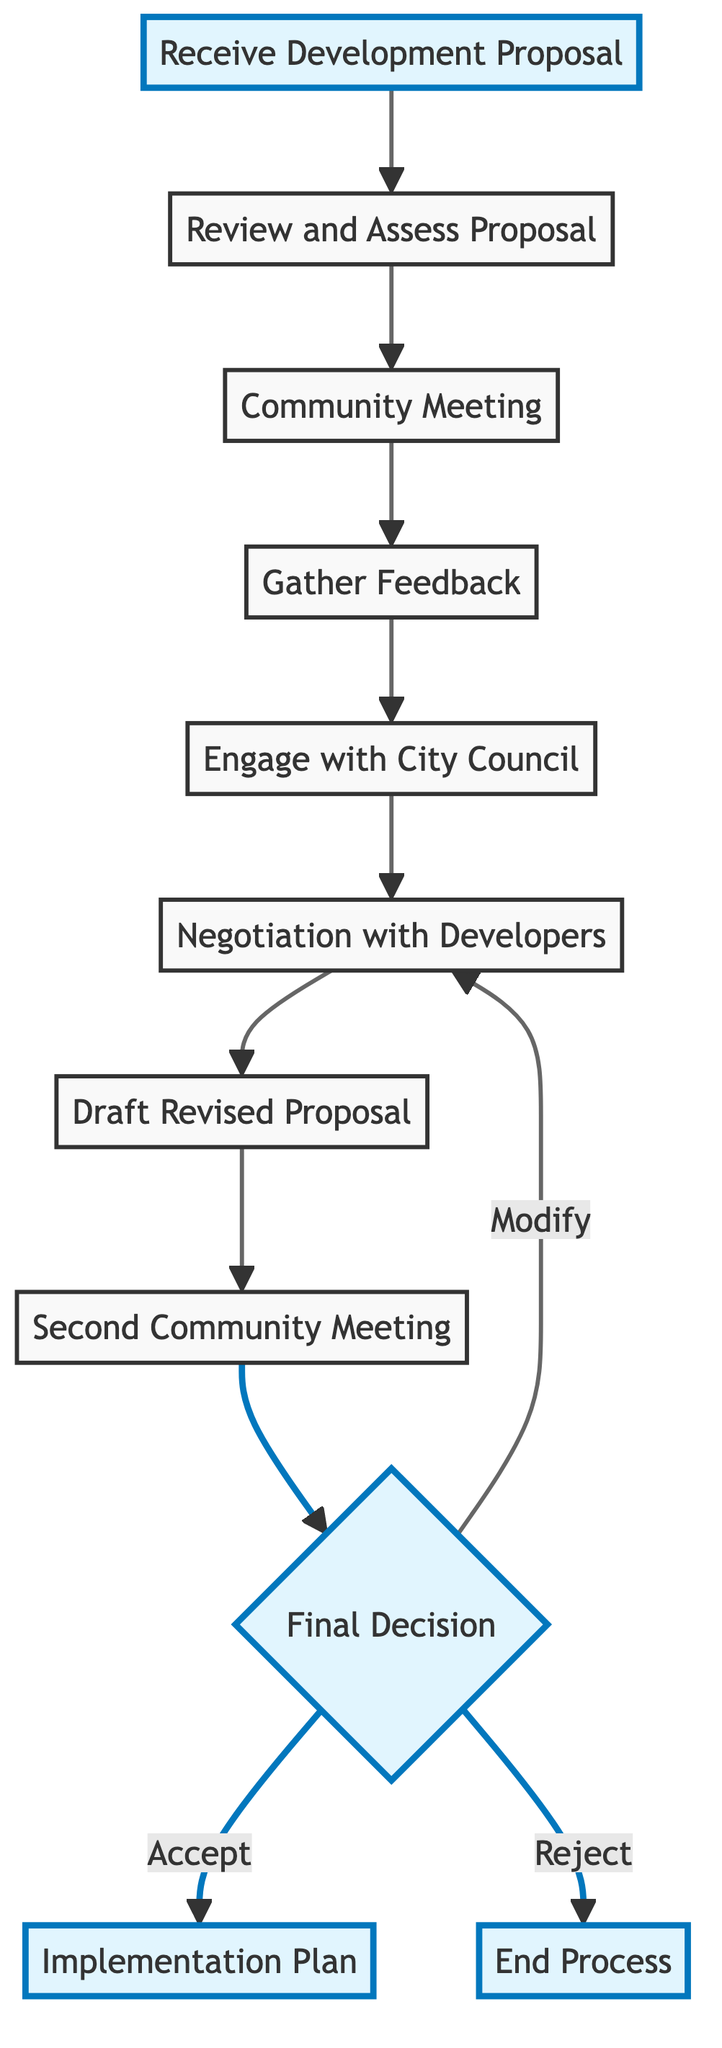What is the starting point of the process? The starting point in the flow chart is the "Receive Development Proposal" node. This is the first action taken in the conflict resolution process when documentation of a new development proposal is received by the farmer.
Answer: Receive Development Proposal How many total nodes are in the diagram? There are ten nodes depicted in the diagram, which represent different steps in the conflict resolution process from receiving a proposal to planning for implementation.
Answer: Ten What comes immediately after "Gather Feedback"? The "Engage with City Council" node follows immediately after "Gather Feedback." After collecting feedback from the community, the next step is to present it to the city council.
Answer: Engage with City Council What is the decision point in the flow chart? The decision point in the flow chart is indicated by the "Final Decision" node. This is where a choice is made regarding the fate of the revised development proposal.
Answer: Final Decision What happens if the revised proposal is rejected? If the revised proposal is rejected, the process ends without any further action being taken. This is shown as a direct connection from the "Final Decision" node to the "End Process" node.
Answer: End Process How many times is "Community Meeting" held in the process? The "Community Meeting" is held twice in the process: once to gather initial reactions and again to present the revised proposal.
Answer: Twice What is the relationship between "Negotiation with Developers" and "Draft Revised Proposal"? "Negotiation with Developers" leads directly to "Draft Revised Proposal;" after negotiations are completed, a revised proposal is created that takes into account community feedback.
Answer: Direct connection What action occurs after the "Second Community Meeting"? After the "Second Community Meeting," the next action is taken at the "Final Decision" node, where decisions regarding the proposal are made based on community discussions.
Answer: Final Decision What happens if the decision is to modify the proposal? If the decision is to modify the proposal, the process loops back to the "Negotiation with Developers" node, indicating further discussions are needed before drafting a revised proposal again.
Answer: Negotiation with Developers 